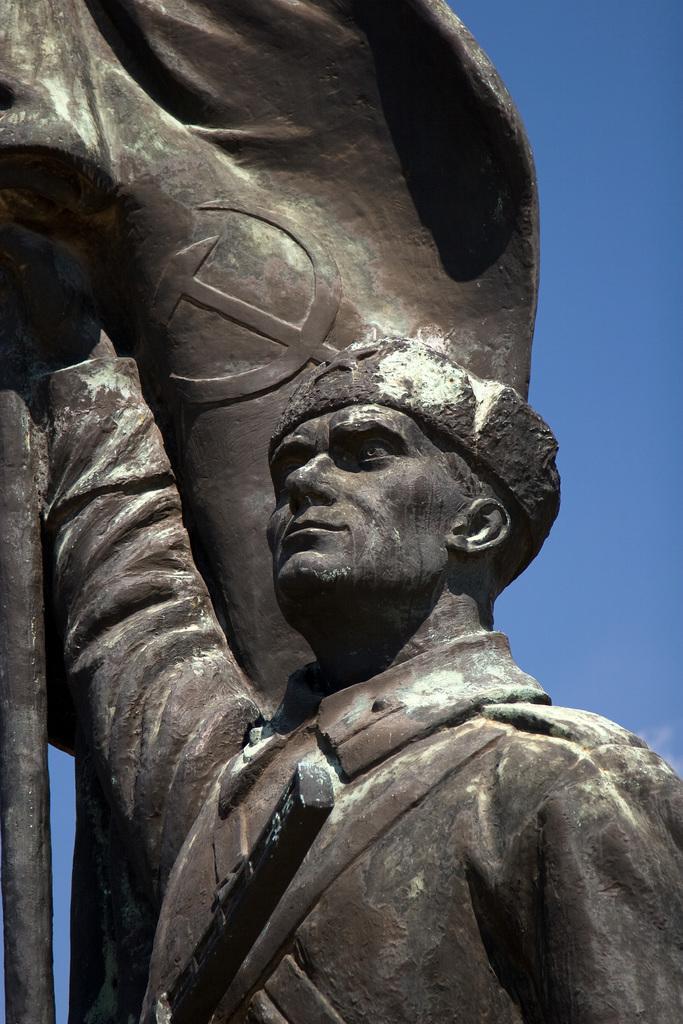In one or two sentences, can you explain what this image depicts? It is a sculpture of a man holding a flag. 